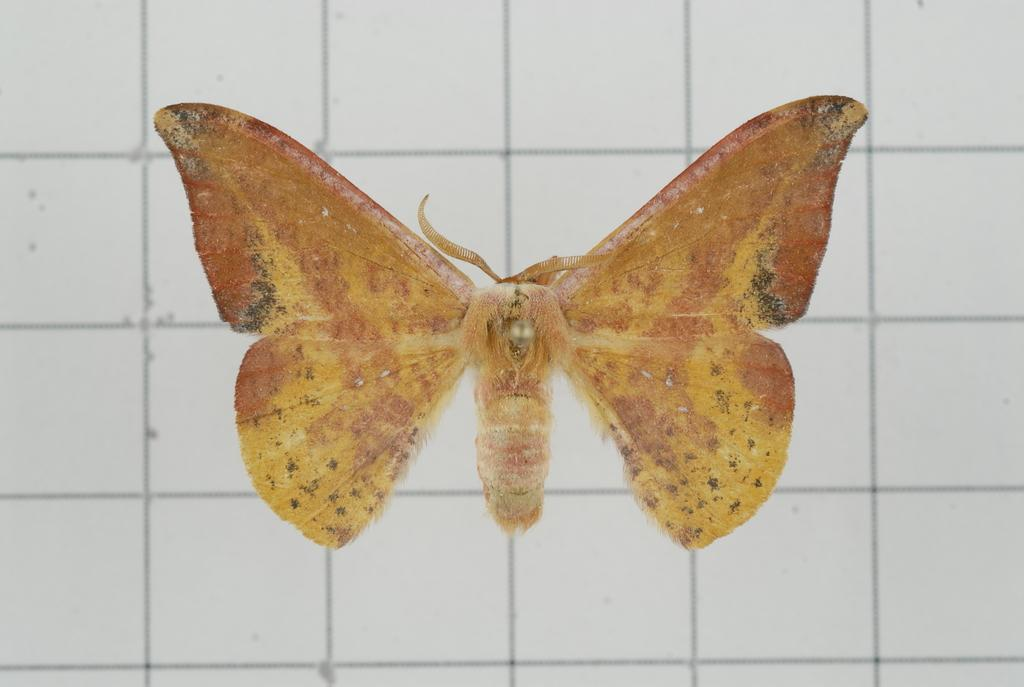What type of animal can be seen in the image? There is a butterfly in the image. Can you describe the background of the image? There is an object in the background of the image. What type of farm can be seen in the image? There is no farm present in the image; it features a butterfly and an object in the background. What type of stream is visible in the image? There is no stream present in the image. 